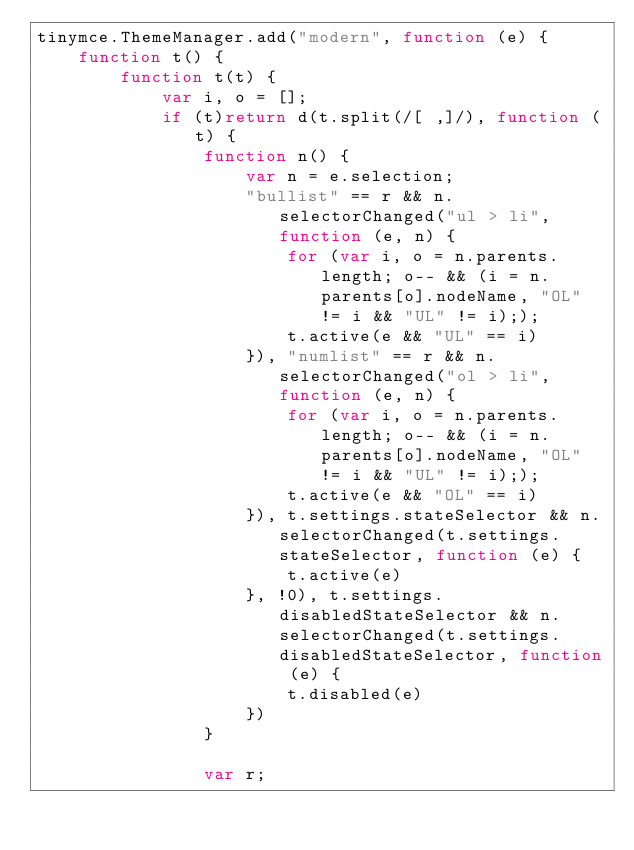<code> <loc_0><loc_0><loc_500><loc_500><_JavaScript_>tinymce.ThemeManager.add("modern", function (e) {
    function t() {
        function t(t) {
            var i, o = [];
            if (t)return d(t.split(/[ ,]/), function (t) {
                function n() {
                    var n = e.selection;
                    "bullist" == r && n.selectorChanged("ul > li", function (e, n) {
                        for (var i, o = n.parents.length; o-- && (i = n.parents[o].nodeName, "OL" != i && "UL" != i););
                        t.active(e && "UL" == i)
                    }), "numlist" == r && n.selectorChanged("ol > li", function (e, n) {
                        for (var i, o = n.parents.length; o-- && (i = n.parents[o].nodeName, "OL" != i && "UL" != i););
                        t.active(e && "OL" == i)
                    }), t.settings.stateSelector && n.selectorChanged(t.settings.stateSelector, function (e) {
                        t.active(e)
                    }, !0), t.settings.disabledStateSelector && n.selectorChanged(t.settings.disabledStateSelector, function (e) {
                        t.disabled(e)
                    })
                }

                var r;</code> 